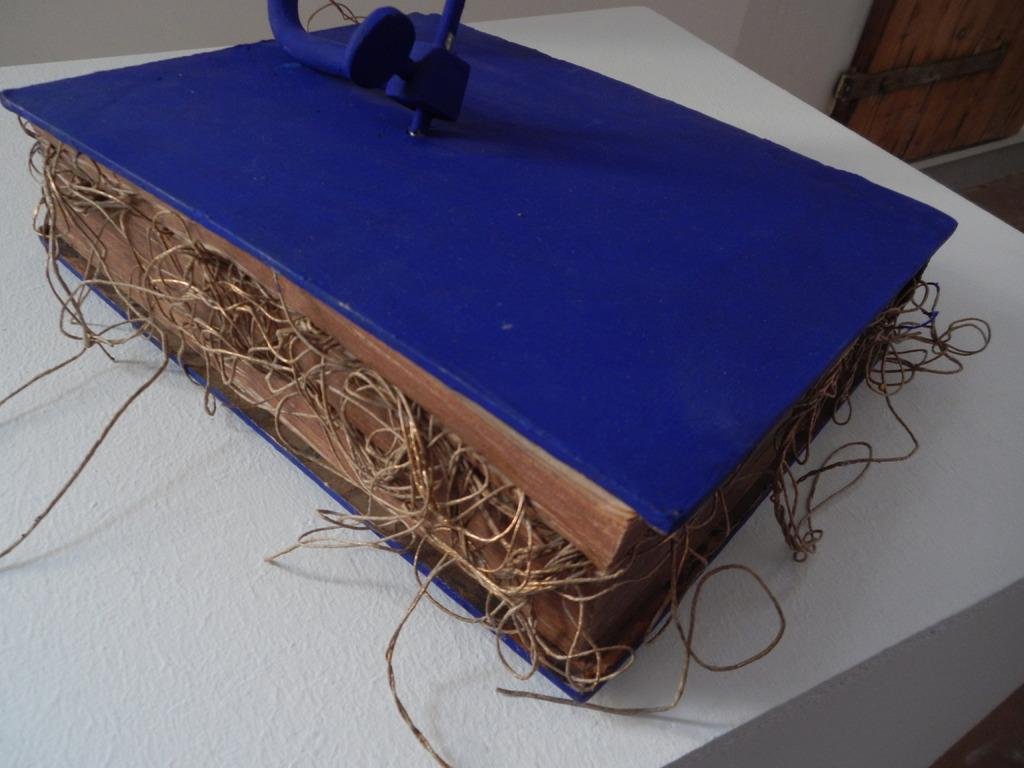What is the color of the box in the image? The box in the image is blue. What is inside the box? Wires are present in the box. Where is the box located? The box is placed on a table. What type of dog can be seen playing with a beef stamp in the image? There is no dog or beef stamp present in the image; it only features a blue color box with wires inside. 